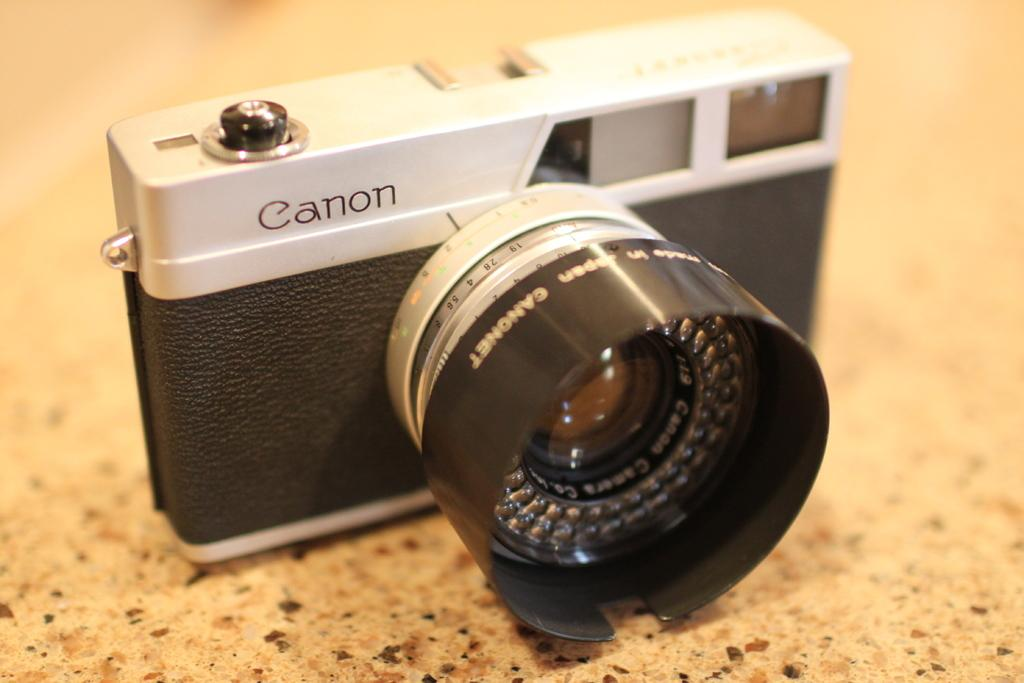What object is on the floor in the image? There is a camera on the floor in the image. What can be seen on the camera itself? There is text and numbers on the camera. How would you describe the background of the image? The background of the image is blurred. What type of sponge is being used to clean the cactus in the image? There is no sponge or cactus present in the image; it features a camera on the floor with text and numbers. 